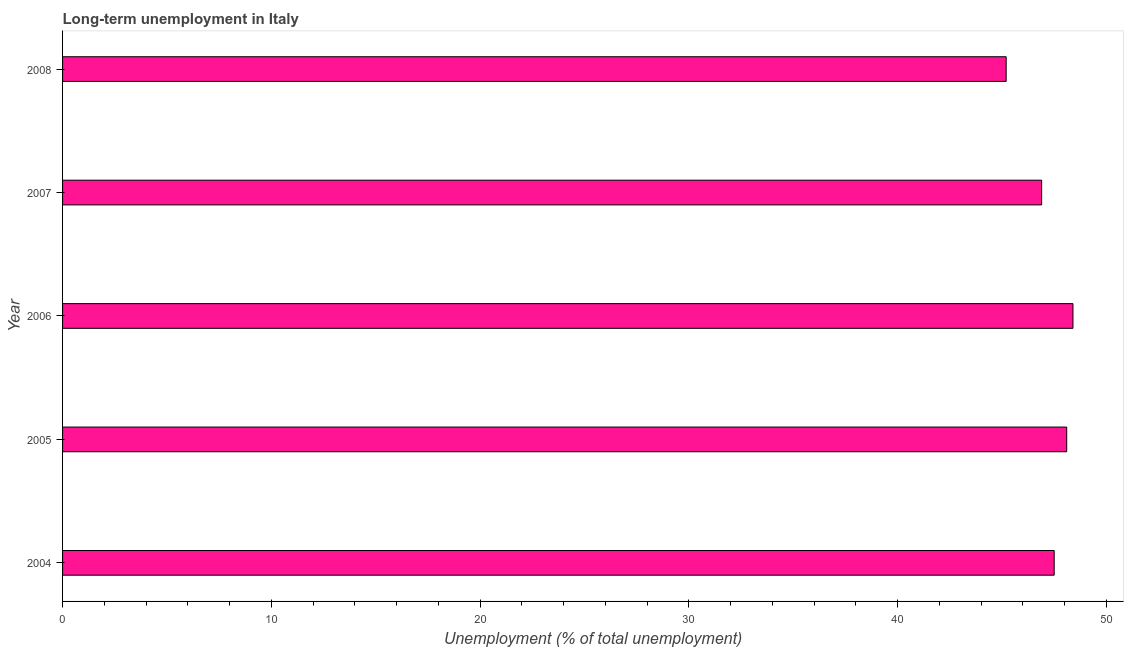Does the graph contain any zero values?
Your response must be concise. No. What is the title of the graph?
Make the answer very short. Long-term unemployment in Italy. What is the label or title of the X-axis?
Provide a succinct answer. Unemployment (% of total unemployment). What is the label or title of the Y-axis?
Offer a terse response. Year. What is the long-term unemployment in 2008?
Provide a succinct answer. 45.2. Across all years, what is the maximum long-term unemployment?
Offer a terse response. 48.4. Across all years, what is the minimum long-term unemployment?
Offer a terse response. 45.2. In which year was the long-term unemployment maximum?
Make the answer very short. 2006. In which year was the long-term unemployment minimum?
Provide a short and direct response. 2008. What is the sum of the long-term unemployment?
Provide a short and direct response. 236.1. What is the average long-term unemployment per year?
Provide a succinct answer. 47.22. What is the median long-term unemployment?
Keep it short and to the point. 47.5. What is the ratio of the long-term unemployment in 2006 to that in 2008?
Ensure brevity in your answer.  1.07. Is the difference between the long-term unemployment in 2005 and 2006 greater than the difference between any two years?
Your response must be concise. No. What is the difference between the highest and the second highest long-term unemployment?
Offer a very short reply. 0.3. What is the difference between the highest and the lowest long-term unemployment?
Ensure brevity in your answer.  3.2. In how many years, is the long-term unemployment greater than the average long-term unemployment taken over all years?
Your answer should be very brief. 3. How many bars are there?
Ensure brevity in your answer.  5. Are all the bars in the graph horizontal?
Make the answer very short. Yes. How many years are there in the graph?
Your response must be concise. 5. Are the values on the major ticks of X-axis written in scientific E-notation?
Provide a succinct answer. No. What is the Unemployment (% of total unemployment) in 2004?
Offer a very short reply. 47.5. What is the Unemployment (% of total unemployment) in 2005?
Make the answer very short. 48.1. What is the Unemployment (% of total unemployment) in 2006?
Offer a terse response. 48.4. What is the Unemployment (% of total unemployment) in 2007?
Your answer should be very brief. 46.9. What is the Unemployment (% of total unemployment) in 2008?
Your answer should be compact. 45.2. What is the difference between the Unemployment (% of total unemployment) in 2004 and 2006?
Provide a short and direct response. -0.9. What is the difference between the Unemployment (% of total unemployment) in 2004 and 2007?
Keep it short and to the point. 0.6. What is the difference between the Unemployment (% of total unemployment) in 2004 and 2008?
Your answer should be compact. 2.3. What is the difference between the Unemployment (% of total unemployment) in 2005 and 2006?
Provide a succinct answer. -0.3. What is the difference between the Unemployment (% of total unemployment) in 2005 and 2007?
Provide a succinct answer. 1.2. What is the difference between the Unemployment (% of total unemployment) in 2005 and 2008?
Your answer should be very brief. 2.9. What is the difference between the Unemployment (% of total unemployment) in 2006 and 2007?
Your answer should be very brief. 1.5. What is the ratio of the Unemployment (% of total unemployment) in 2004 to that in 2006?
Your answer should be very brief. 0.98. What is the ratio of the Unemployment (% of total unemployment) in 2004 to that in 2008?
Offer a very short reply. 1.05. What is the ratio of the Unemployment (% of total unemployment) in 2005 to that in 2006?
Offer a terse response. 0.99. What is the ratio of the Unemployment (% of total unemployment) in 2005 to that in 2008?
Provide a short and direct response. 1.06. What is the ratio of the Unemployment (% of total unemployment) in 2006 to that in 2007?
Offer a terse response. 1.03. What is the ratio of the Unemployment (% of total unemployment) in 2006 to that in 2008?
Ensure brevity in your answer.  1.07. What is the ratio of the Unemployment (% of total unemployment) in 2007 to that in 2008?
Your answer should be compact. 1.04. 